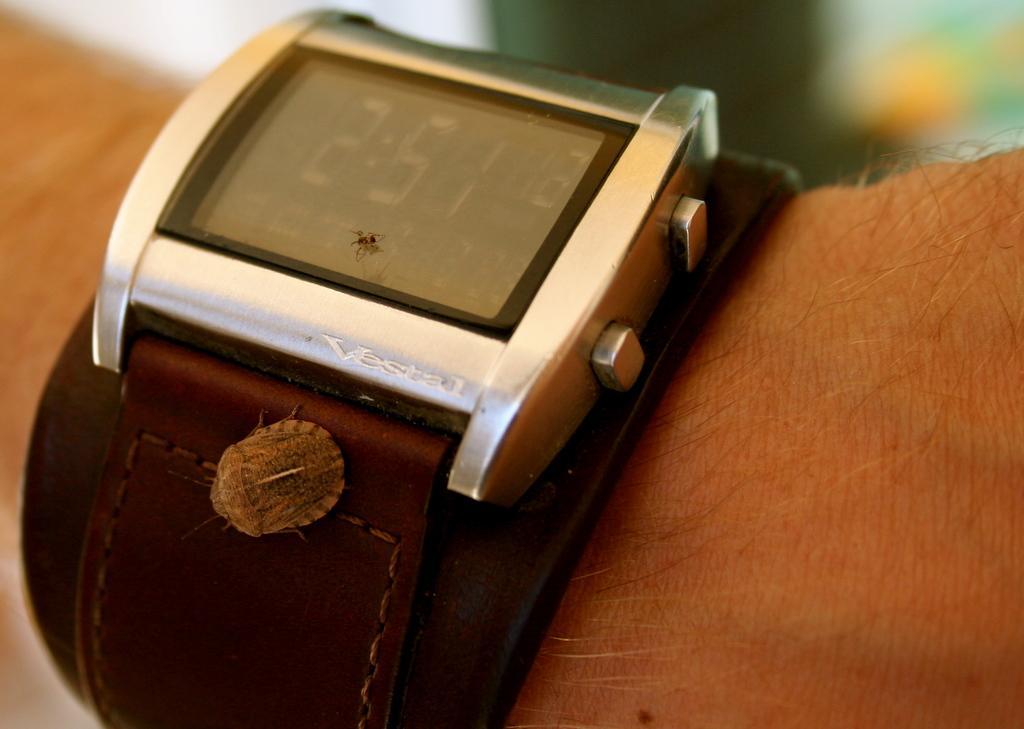Could you give a brief overview of what you see in this image? In this image we can see a wrist watch on the person's hand. We can also see some insects on it. 